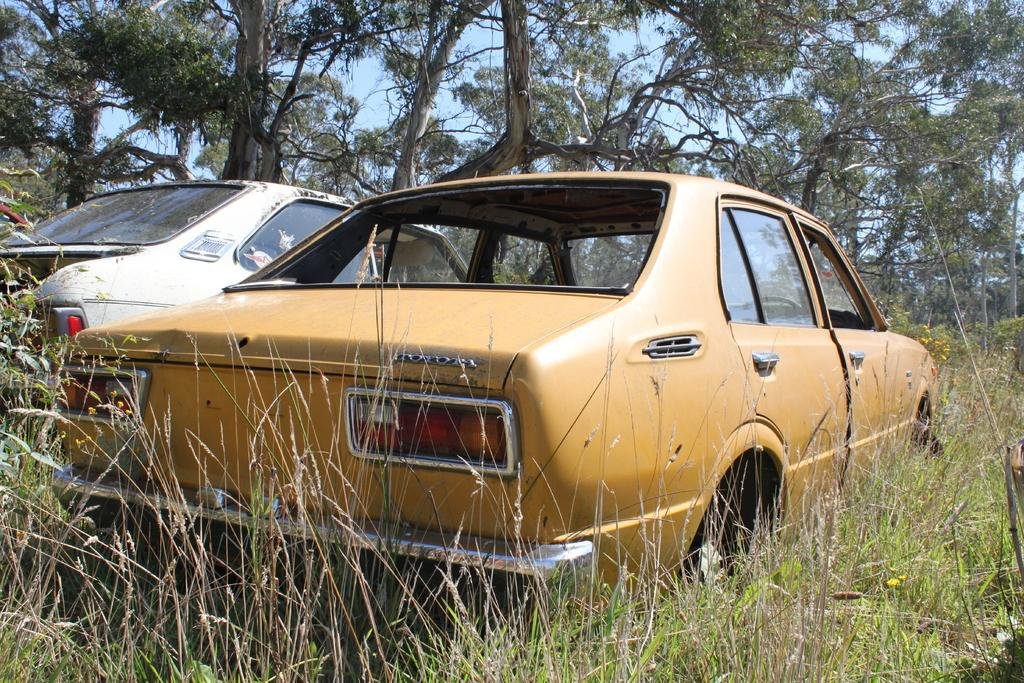What can be seen on the ground in the image? There are two vehicles on the ground in the image. What type of natural scenery is visible in the background? There are trees visible in the background. What else can be seen in the background of the image? The sky is visible in the background. What type of pest can be seen crawling on the vehicles in the image? There are no pests visible on the vehicles in the image. How many trucks are present in the image? The image does not specify the type of vehicles, so we cannot determine if they are trucks or not. 